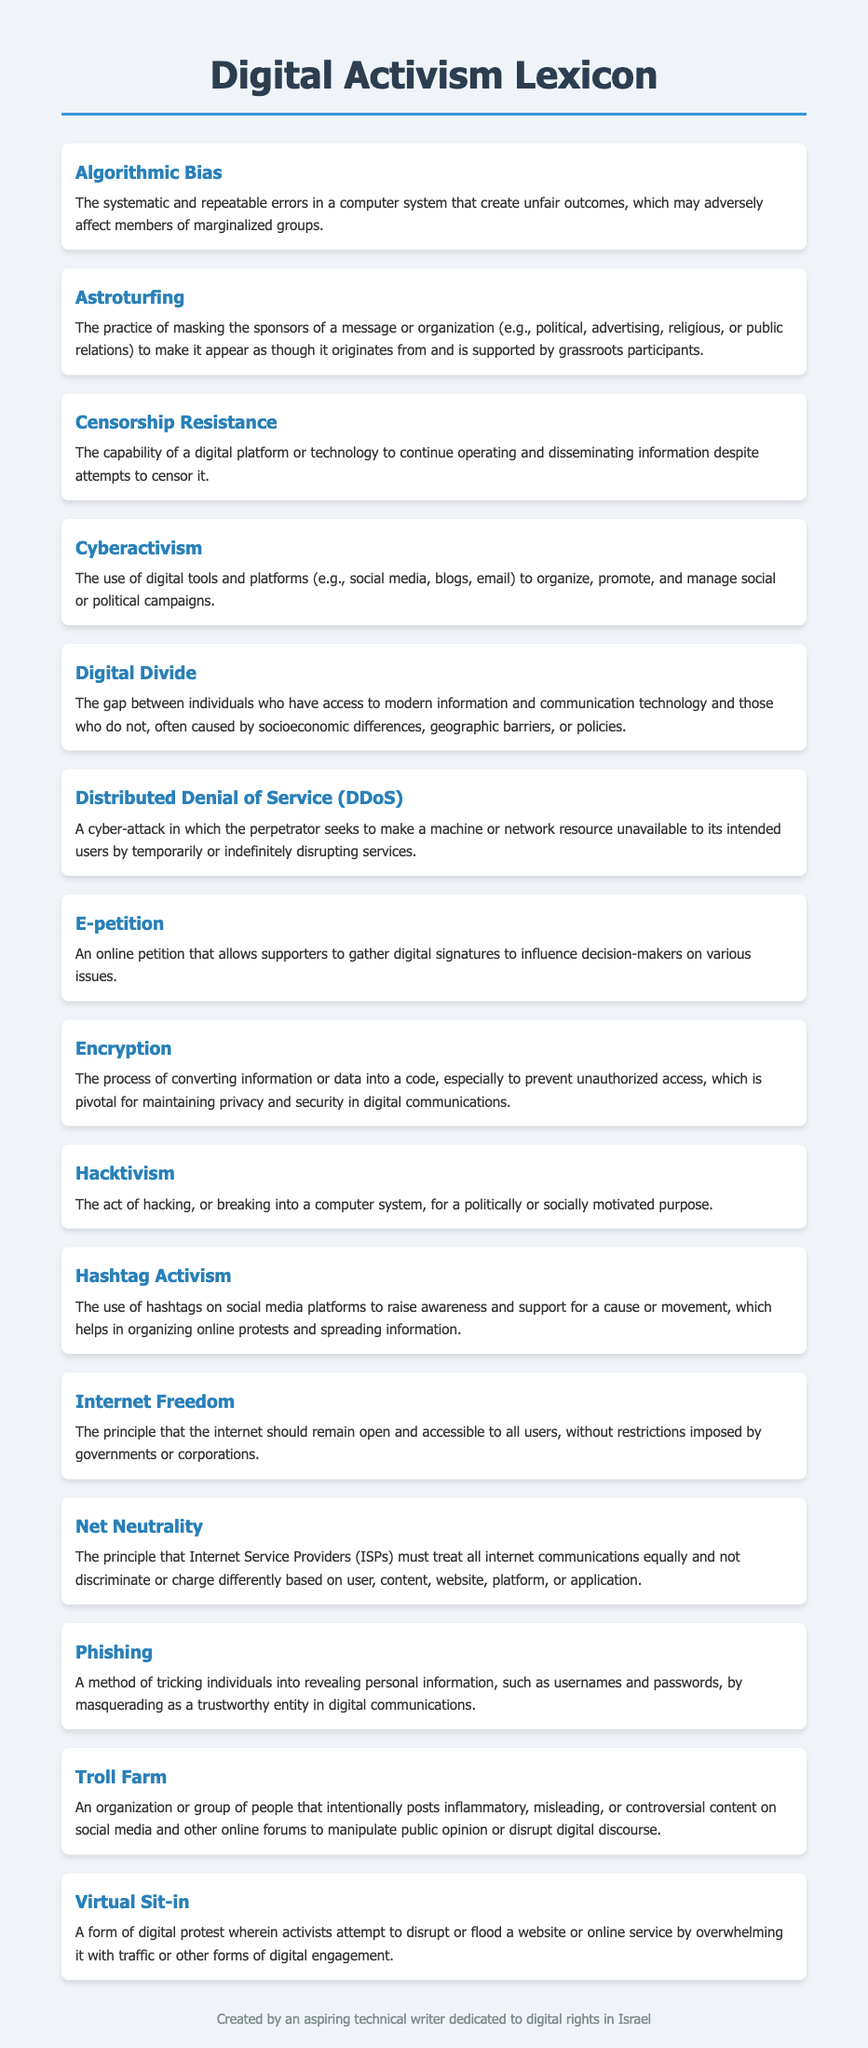What is the term for systematic errors in a computer system? The term is used to describe systematic and repeatable errors that adversely affect marginalized groups, which is known as algorithmic bias.
Answer: Algorithmic Bias What does "DDoS" stand for? In the context of cyber-attacks, DDoS stands for Distributed Denial of Service.
Answer: Distributed Denial of Service What kind of digital tool is used for organizing social campaigns? The document defines the use of various digital tools for organizing social or political campaigns, referring to it as cyberactivism.
Answer: Cyberactivism What principle ensures that ISPs treat all internet communications equally? The principle that governs the treatment of internet communications by ISPs is known as net neutrality.
Answer: Net Neutrality What is a digital protest that disrupts a website called? The term used to describe a digital protest that overwhelms a website’s traffic is virtual sit-in.
Answer: Virtual Sit-in What are the digital signatures gathered to influence decision-makers called? The document refers to these digital signatures collected online to influence decision-makers as an e-petition.
Answer: E-petition What type of activism involves using hashtags on social media? The practice of using hashtags to promote social causes and movements is known as hashtag activism.
Answer: Hashtag Activism What term describes an organization that spreads misleading content online? The term used for such organizations that intentionally post misleading content is troll farm.
Answer: Troll Farm 